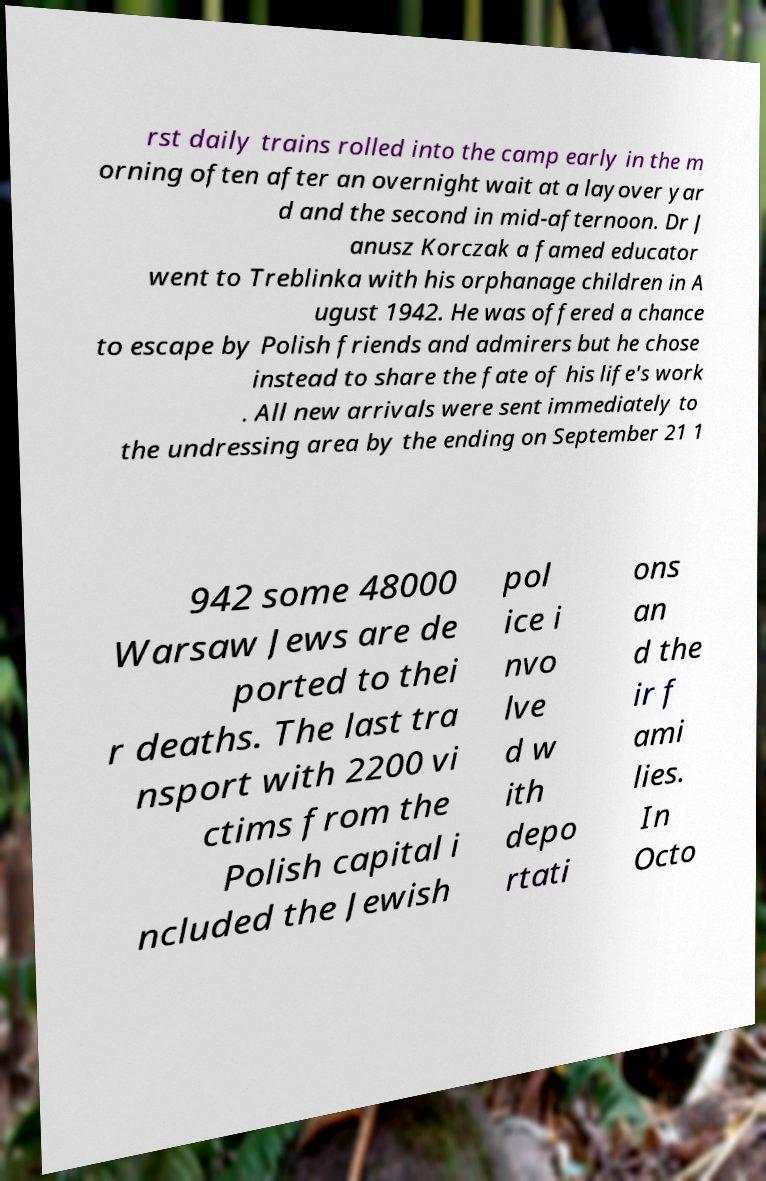For documentation purposes, I need the text within this image transcribed. Could you provide that? rst daily trains rolled into the camp early in the m orning often after an overnight wait at a layover yar d and the second in mid-afternoon. Dr J anusz Korczak a famed educator went to Treblinka with his orphanage children in A ugust 1942. He was offered a chance to escape by Polish friends and admirers but he chose instead to share the fate of his life's work . All new arrivals were sent immediately to the undressing area by the ending on September 21 1 942 some 48000 Warsaw Jews are de ported to thei r deaths. The last tra nsport with 2200 vi ctims from the Polish capital i ncluded the Jewish pol ice i nvo lve d w ith depo rtati ons an d the ir f ami lies. In Octo 